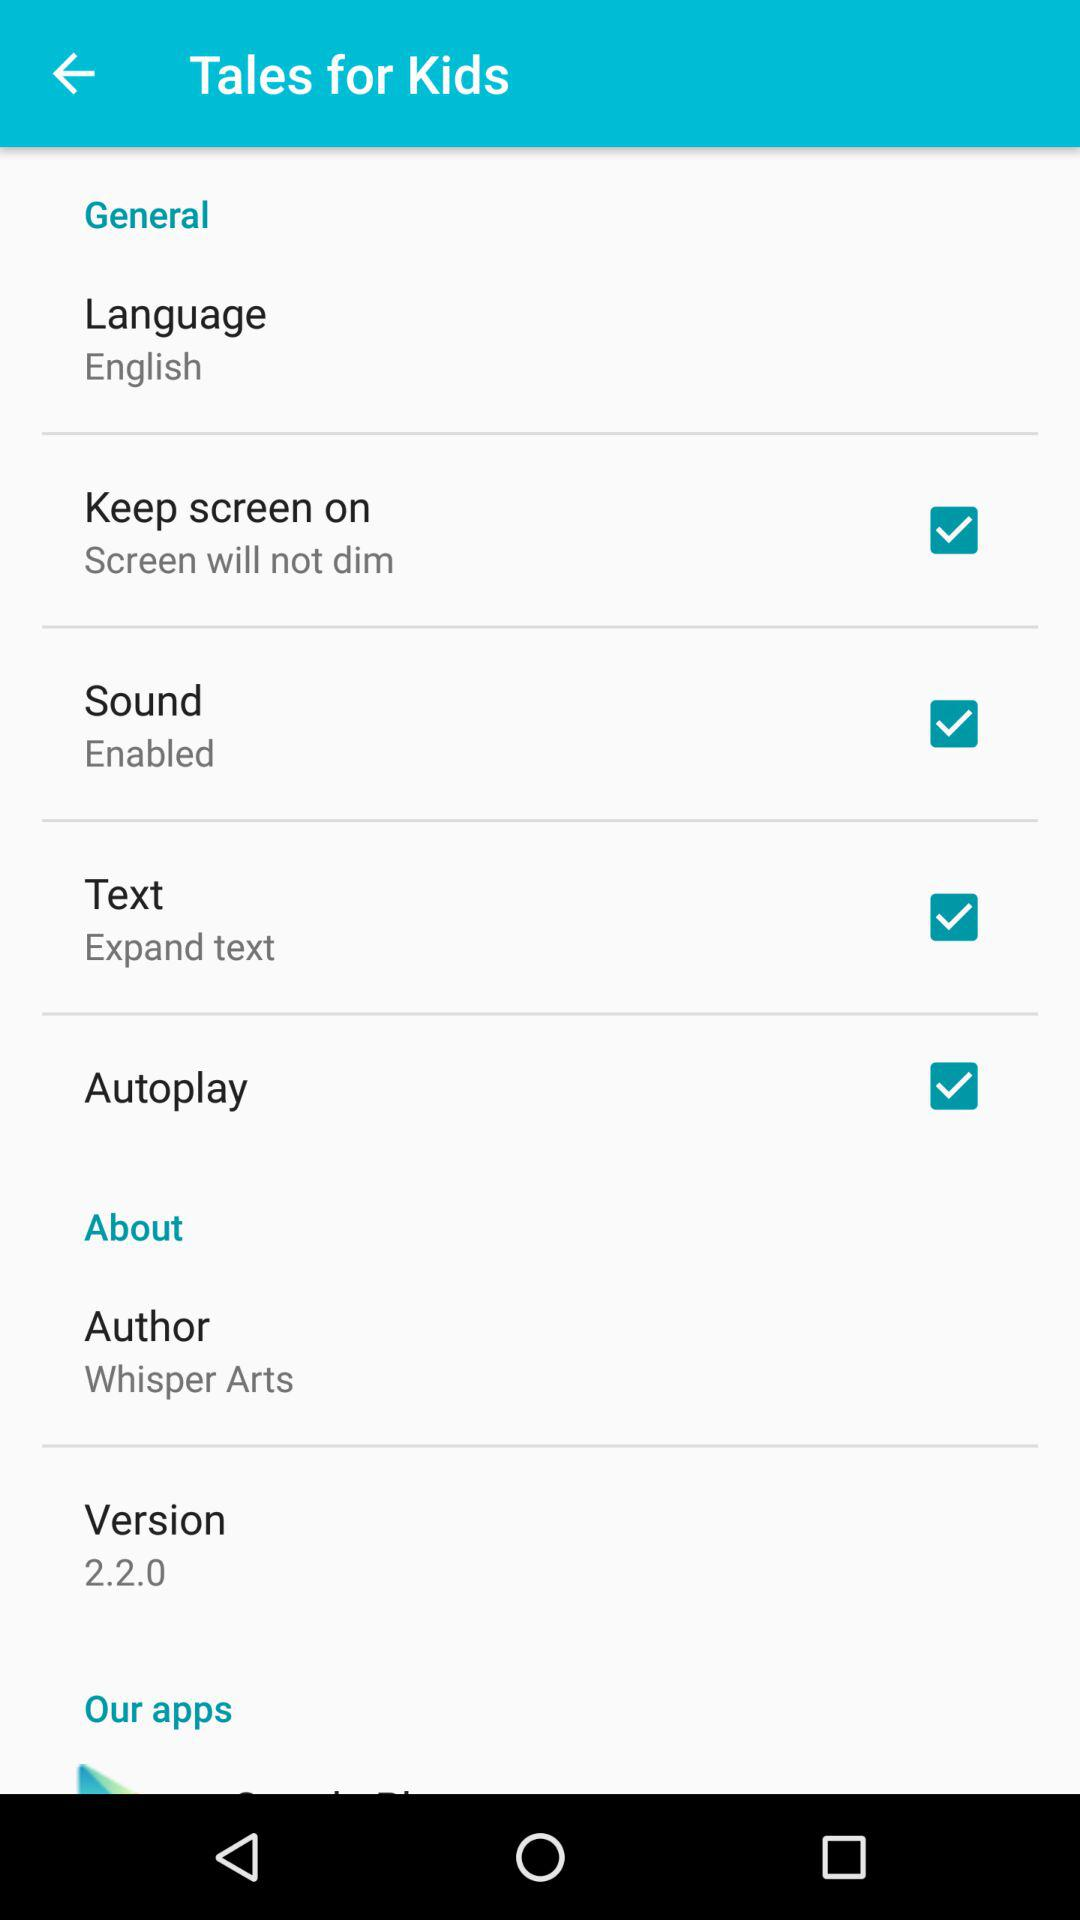Which options are checked? The checked options are "Keep screen on", "Sound", "Text" and "Autoplay". 